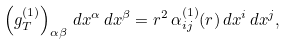Convert formula to latex. <formula><loc_0><loc_0><loc_500><loc_500>\left ( g ^ { ( 1 ) } _ { T } \right ) _ { \alpha \beta } \, d x ^ { \alpha } \, d x ^ { \beta } = r ^ { 2 } \, \alpha ^ { ( 1 ) } _ { i j } ( r ) \, d x ^ { i } \, d x ^ { j } ,</formula> 